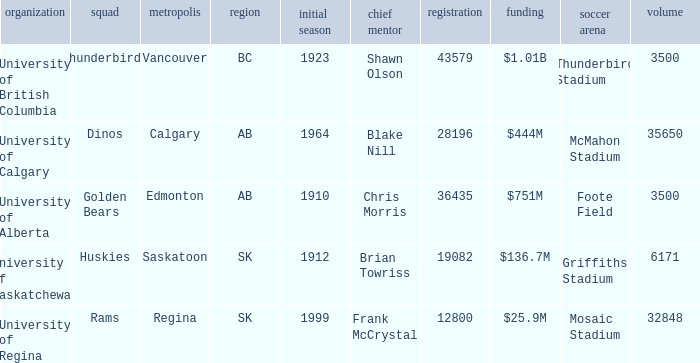How many cities have an enrollment of 19082? 1.0. 